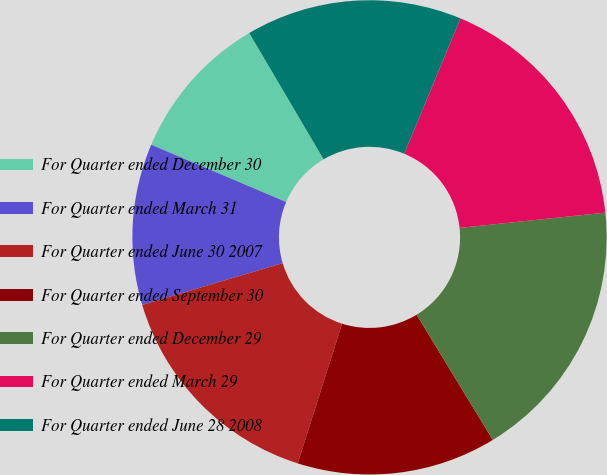Convert chart to OTSL. <chart><loc_0><loc_0><loc_500><loc_500><pie_chart><fcel>For Quarter ended December 30<fcel>For Quarter ended March 31<fcel>For Quarter ended June 30 2007<fcel>For Quarter ended September 30<fcel>For Quarter ended December 29<fcel>For Quarter ended March 29<fcel>For Quarter ended June 28 2008<nl><fcel>10.15%<fcel>10.98%<fcel>15.51%<fcel>13.6%<fcel>17.96%<fcel>17.07%<fcel>14.73%<nl></chart> 